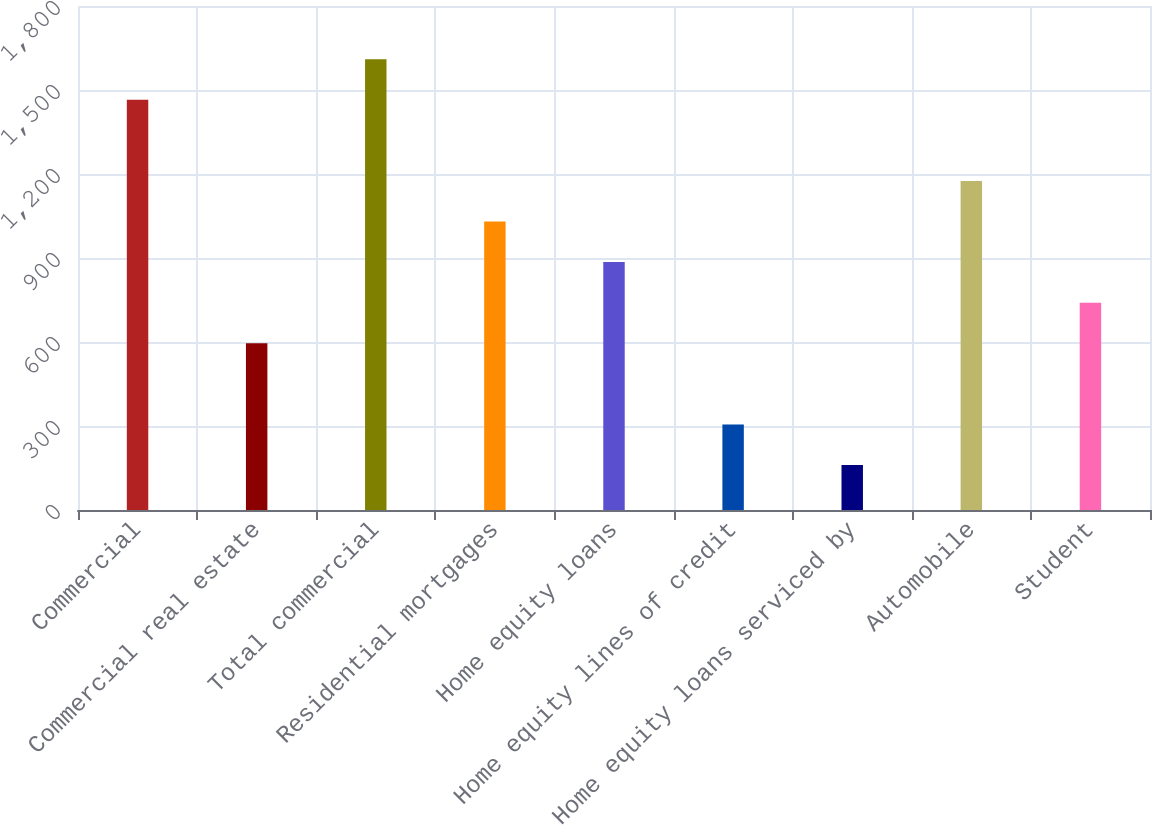Convert chart to OTSL. <chart><loc_0><loc_0><loc_500><loc_500><bar_chart><fcel>Commercial<fcel>Commercial real estate<fcel>Total commercial<fcel>Residential mortgages<fcel>Home equity loans<fcel>Home equity lines of credit<fcel>Home equity loans serviced by<fcel>Automobile<fcel>Student<nl><fcel>1465<fcel>595.6<fcel>1609.9<fcel>1030.3<fcel>885.4<fcel>305.8<fcel>160.9<fcel>1175.2<fcel>740.5<nl></chart> 